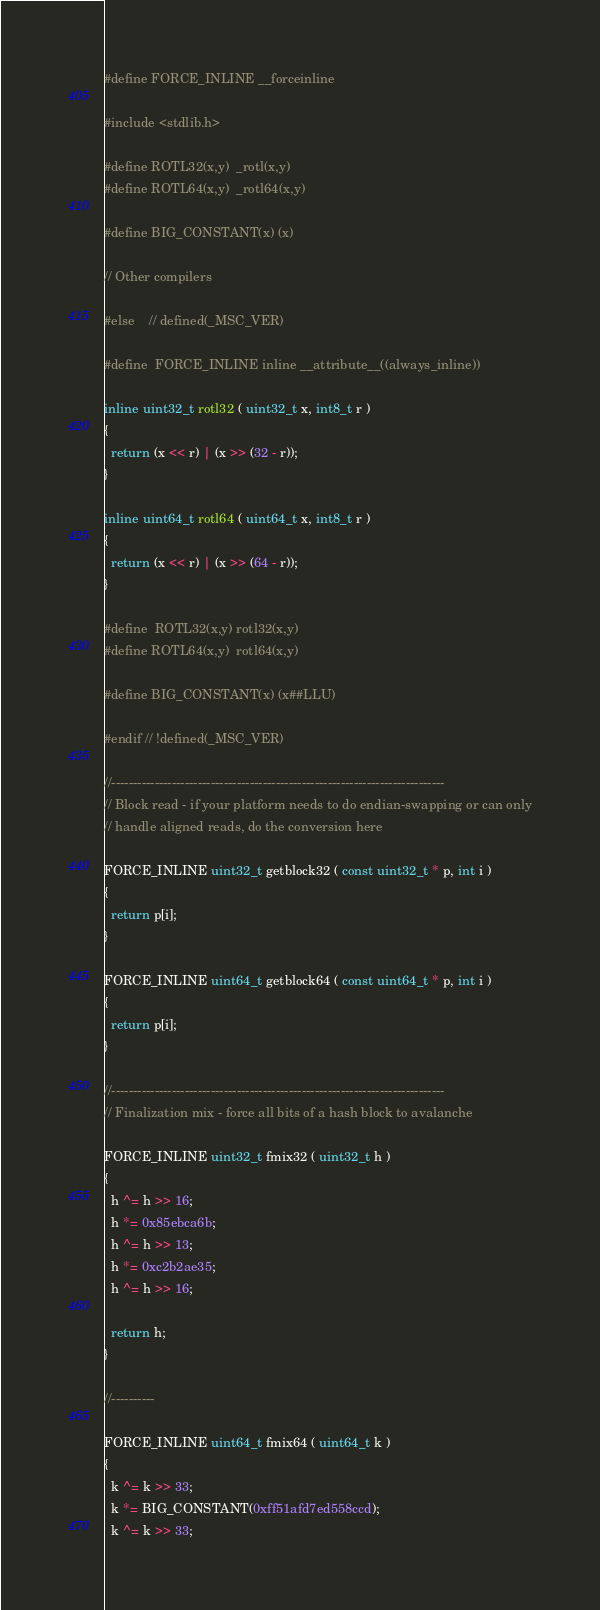Convert code to text. <code><loc_0><loc_0><loc_500><loc_500><_C++_>#define FORCE_INLINE	__forceinline

#include <stdlib.h>

#define ROTL32(x,y)	_rotl(x,y)
#define ROTL64(x,y)	_rotl64(x,y)

#define BIG_CONSTANT(x) (x)

// Other compilers

#else	// defined(_MSC_VER)

#define	FORCE_INLINE inline __attribute__((always_inline))

inline uint32_t rotl32 ( uint32_t x, int8_t r )
{
  return (x << r) | (x >> (32 - r));
}

inline uint64_t rotl64 ( uint64_t x, int8_t r )
{
  return (x << r) | (x >> (64 - r));
}

#define	ROTL32(x,y)	rotl32(x,y)
#define ROTL64(x,y)	rotl64(x,y)

#define BIG_CONSTANT(x) (x##LLU)

#endif // !defined(_MSC_VER)

//-----------------------------------------------------------------------------
// Block read - if your platform needs to do endian-swapping or can only
// handle aligned reads, do the conversion here

FORCE_INLINE uint32_t getblock32 ( const uint32_t * p, int i )
{
  return p[i];
}

FORCE_INLINE uint64_t getblock64 ( const uint64_t * p, int i )
{
  return p[i];
}

//-----------------------------------------------------------------------------
// Finalization mix - force all bits of a hash block to avalanche

FORCE_INLINE uint32_t fmix32 ( uint32_t h )
{
  h ^= h >> 16;
  h *= 0x85ebca6b;
  h ^= h >> 13;
  h *= 0xc2b2ae35;
  h ^= h >> 16;

  return h;
}

//----------

FORCE_INLINE uint64_t fmix64 ( uint64_t k )
{
  k ^= k >> 33;
  k *= BIG_CONSTANT(0xff51afd7ed558ccd);
  k ^= k >> 33;</code> 